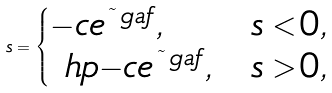<formula> <loc_0><loc_0><loc_500><loc_500>s = \begin{cases} - c e ^ { \tilde { \ } g a f } , & s < 0 , \\ \ h p { - } c e ^ { \tilde { \ } g a f } , & s > 0 , \end{cases}</formula> 